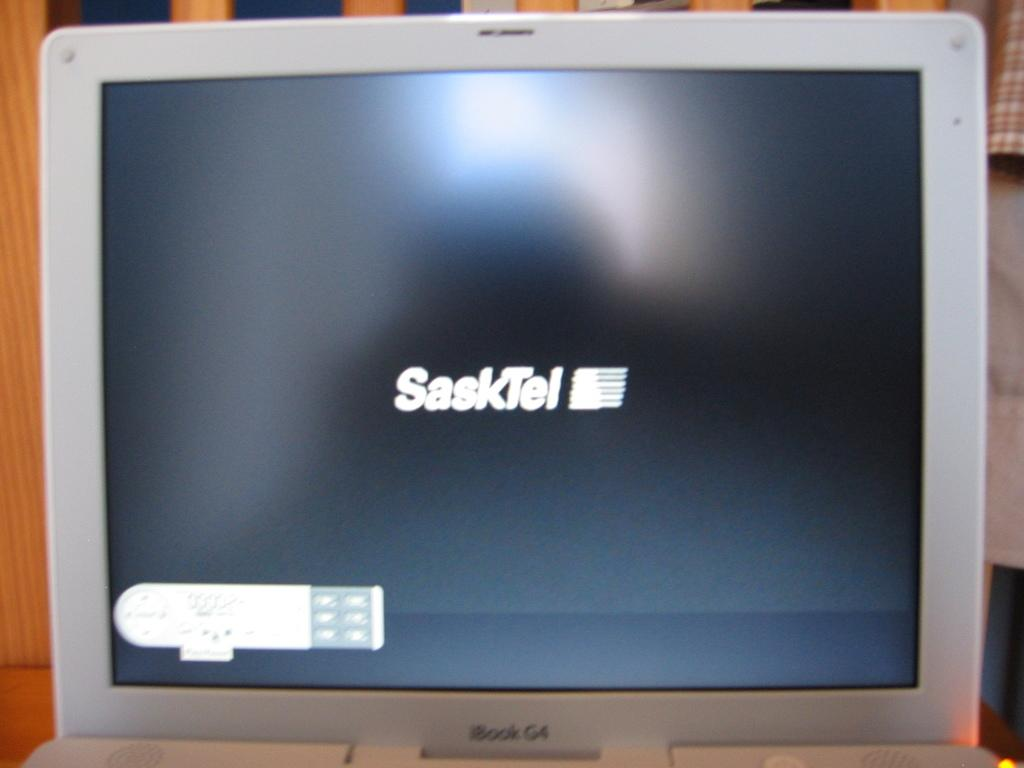<image>
Describe the image concisely. An iBook G4 laptop, displaying the SaskTel logo. 